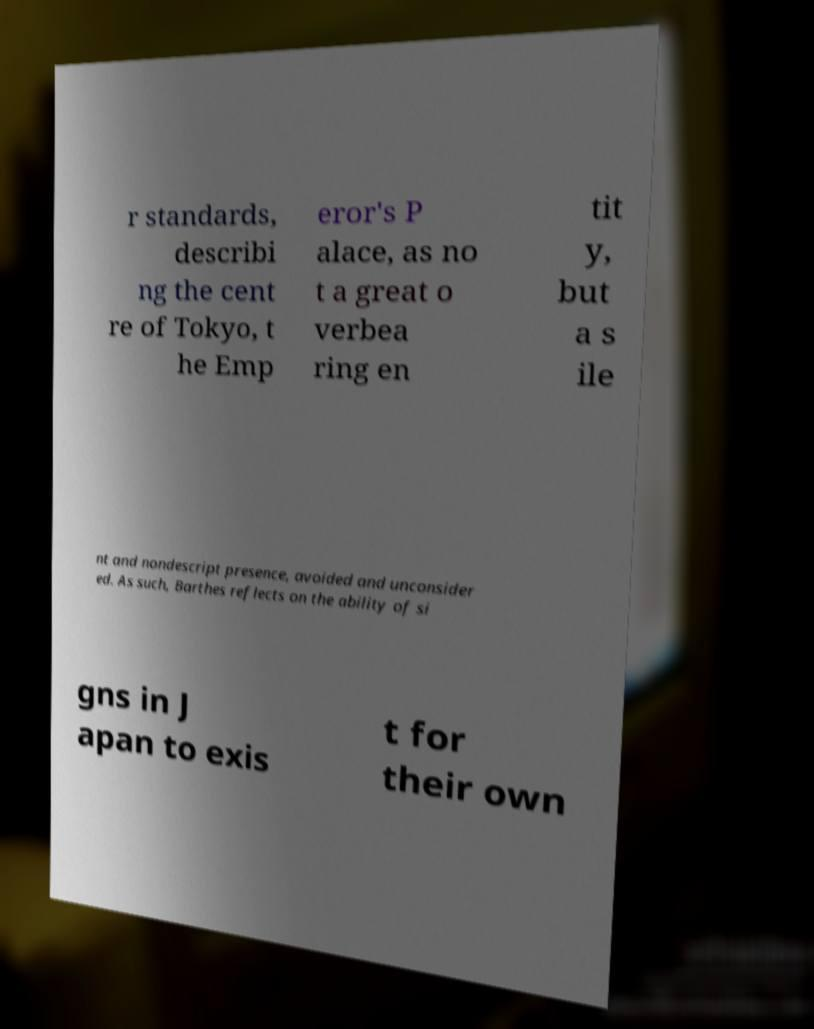For documentation purposes, I need the text within this image transcribed. Could you provide that? r standards, describi ng the cent re of Tokyo, t he Emp eror's P alace, as no t a great o verbea ring en tit y, but a s ile nt and nondescript presence, avoided and unconsider ed. As such, Barthes reflects on the ability of si gns in J apan to exis t for their own 